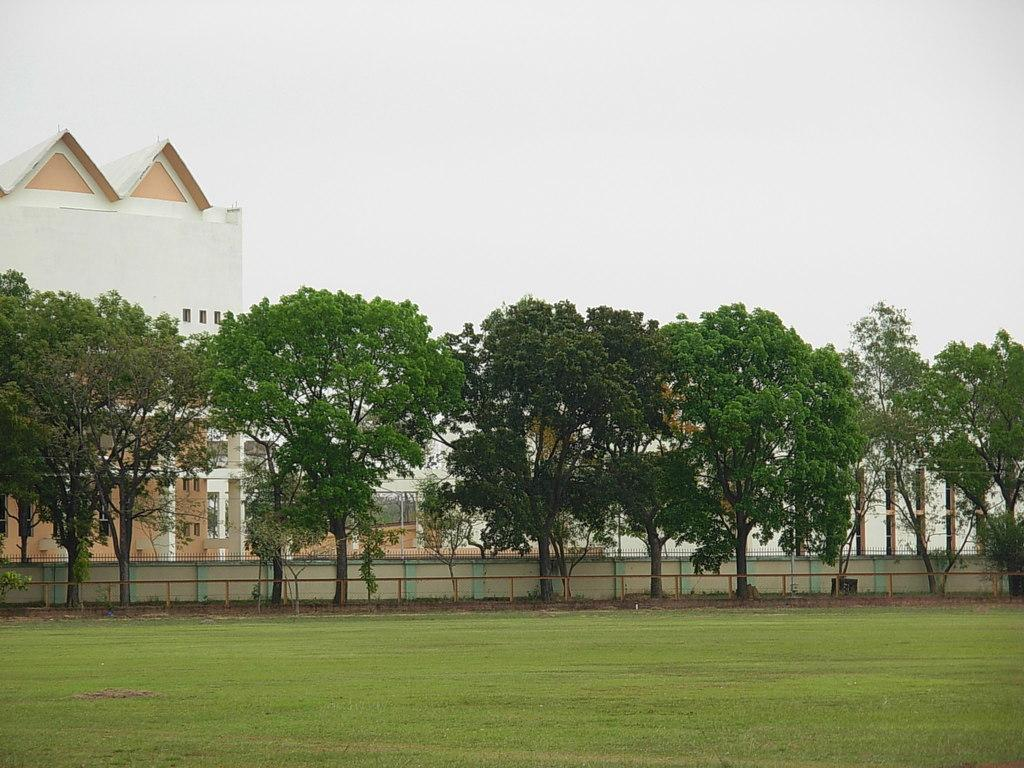What type of outdoor space is depicted in the image? There is a garden in the image. What can be seen behind the garden? There are trees behind the garden. What is located behind the trees? There is a wall behind the trees. What is situated behind the wall? There is a building behind the wall. How many zebras can be seen in the garden in the image? There are no zebras present in the garden or the image. What type of system is responsible for the arrangement of the garden in the image? The image does not provide information about any system responsible for the arrangement of the garden. 